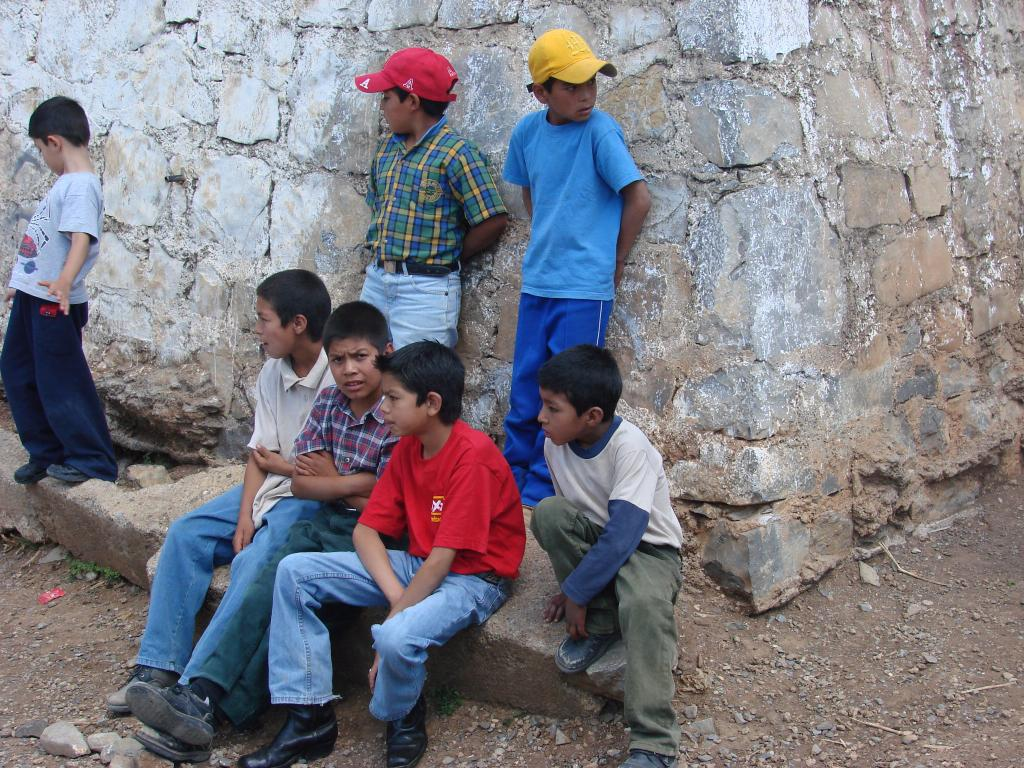How many boys are present in the image? There are four boys sitting in the image. What are the other boys doing in the image? Three boys are standing on rocks in the image. What can be found on the ground in the image? Stones are present on the ground in the image. What can be seen in the distance in the image? A: There is a wall visible in the background of the image. What type of net is being used to catch the pot in the image? There is no net or pot present in the image; it features four boys sitting and three boys standing on rocks. What attraction is the boys visiting in the image? The image does not show the boys visiting any specific attraction; it only shows them sitting and standing on rocks with stones on the ground and a wall in the background. 